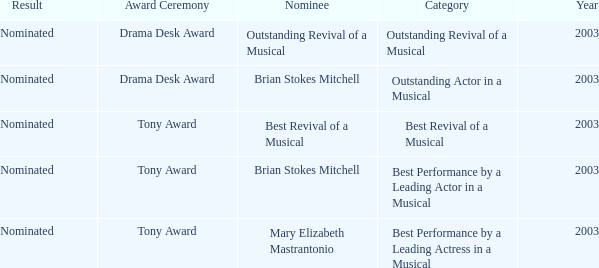Which nominee won the best revival of a musical category? Nominated. 